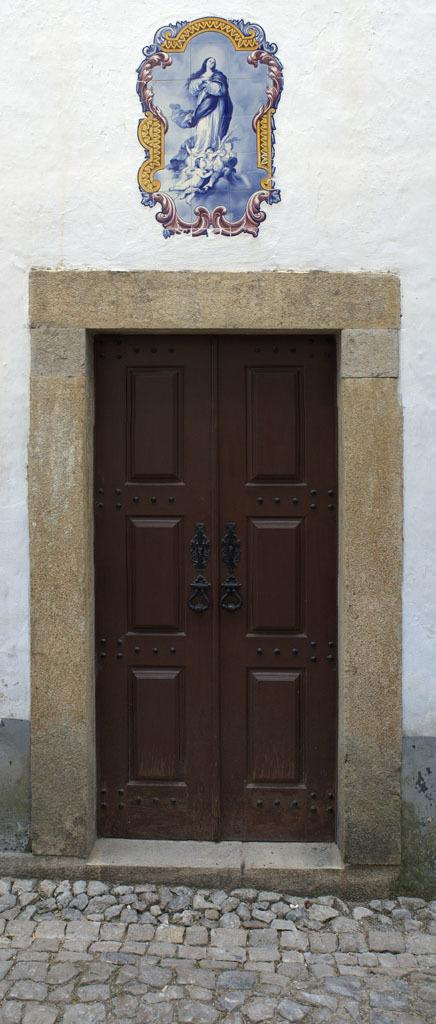What is the main feature of the image? There is a brown door in the image. What else can be seen in the image besides the door? There is a wall in the image. What is the surface beneath the door and wall? The floor is visible in the image. What time of day is it in the image, and what type of scene is being depicted? The time of day and the type of scene being depicted cannot be determined from the image, as it only shows a brown door, a wall, and the floor. Is anyone driving a car in the image? There is no car or any indication of driving in the image. 